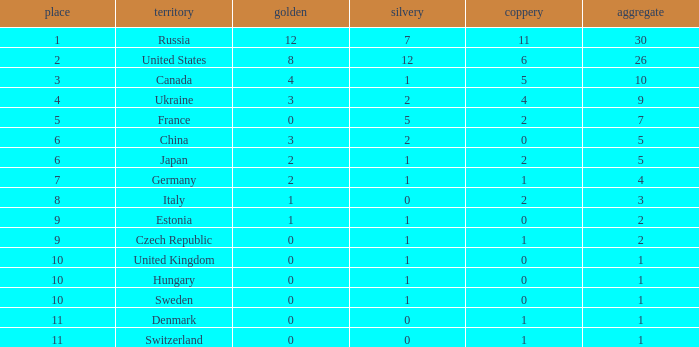How many silvers have a Nation of hungary, and a Rank larger than 10? 0.0. 